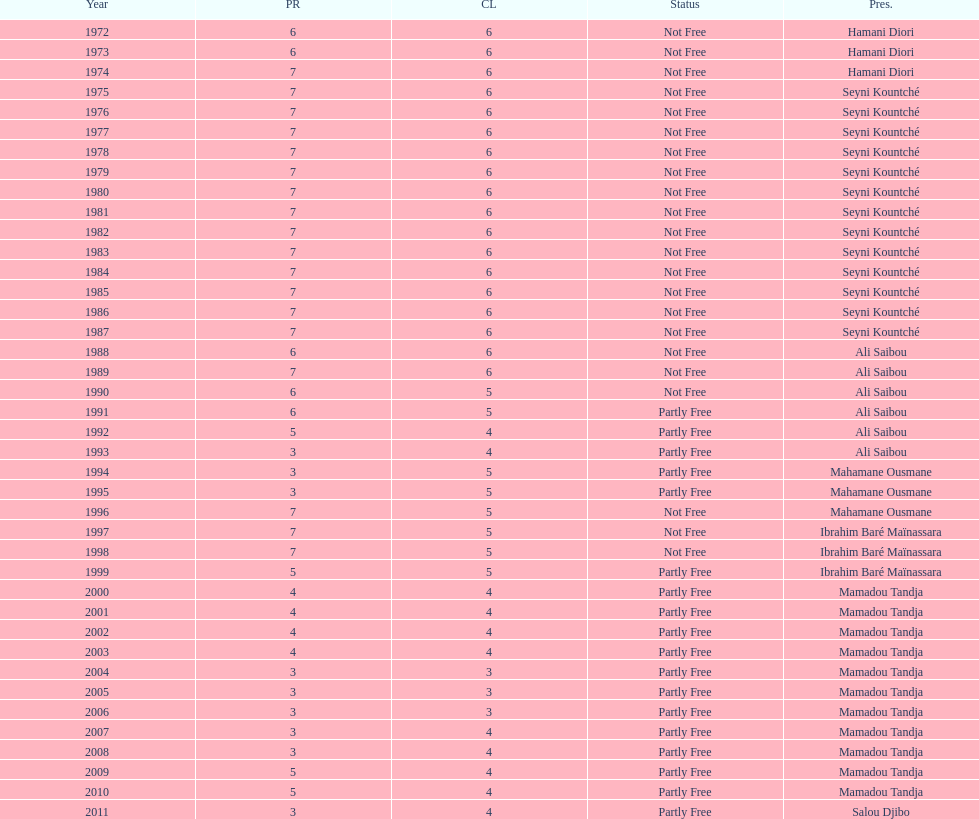How many years was ali saibou president? 6. 